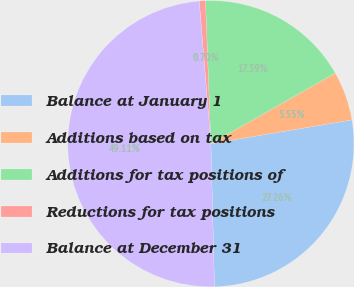<chart> <loc_0><loc_0><loc_500><loc_500><pie_chart><fcel>Balance at January 1<fcel>Additions based on tax<fcel>Additions for tax positions of<fcel>Reductions for tax positions<fcel>Balance at December 31<nl><fcel>27.26%<fcel>5.55%<fcel>17.39%<fcel>0.7%<fcel>49.11%<nl></chart> 